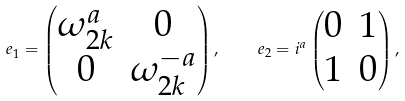Convert formula to latex. <formula><loc_0><loc_0><loc_500><loc_500>e _ { 1 } = \begin{pmatrix} \omega _ { 2 k } ^ { a } & 0 \\ 0 & \omega _ { 2 k } ^ { - a } \end{pmatrix} , \quad e _ { 2 } = i ^ { a } \begin{pmatrix} 0 & 1 \\ 1 & 0 \end{pmatrix} ,</formula> 